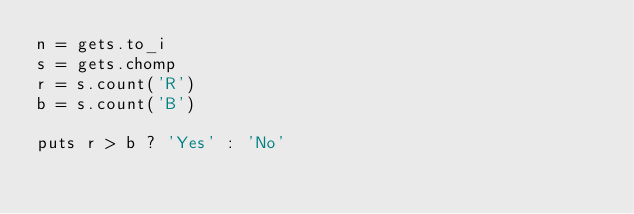<code> <loc_0><loc_0><loc_500><loc_500><_Ruby_>n = gets.to_i
s = gets.chomp
r = s.count('R')
b = s.count('B')

puts r > b ? 'Yes' : 'No'</code> 